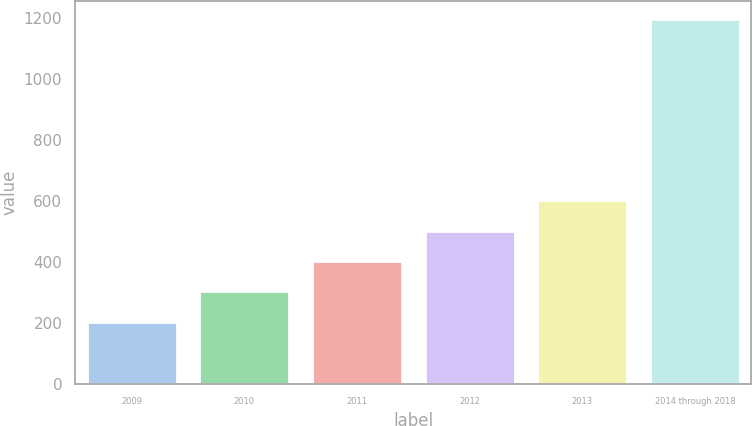Convert chart. <chart><loc_0><loc_0><loc_500><loc_500><bar_chart><fcel>2009<fcel>2010<fcel>2011<fcel>2012<fcel>2013<fcel>2014 through 2018<nl><fcel>205<fcel>304.3<fcel>403.6<fcel>502.9<fcel>602.2<fcel>1198<nl></chart> 